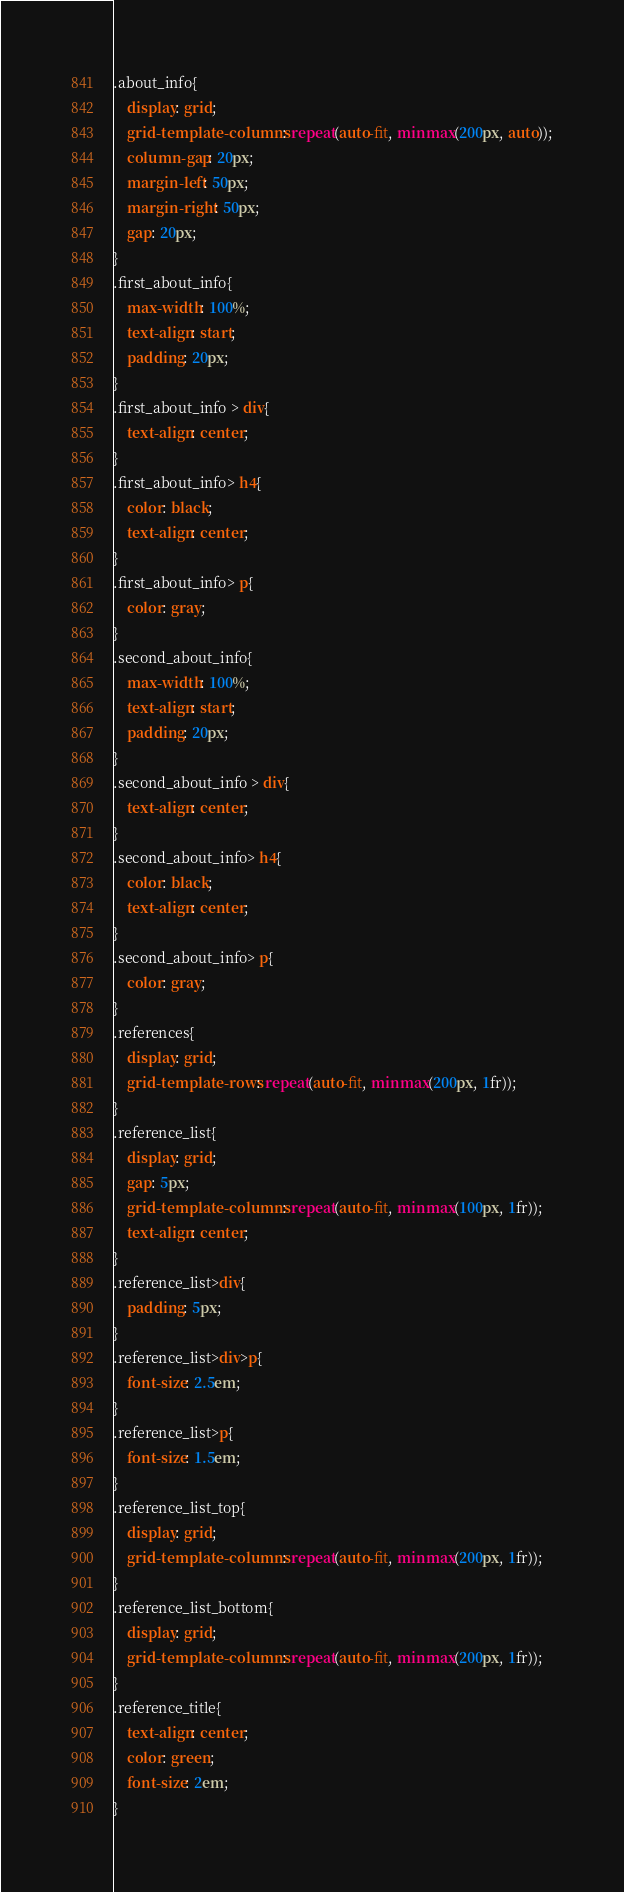Convert code to text. <code><loc_0><loc_0><loc_500><loc_500><_CSS_>.about_info{
    display: grid;
    grid-template-columns: repeat(auto-fit, minmax(200px, auto));
    column-gap: 20px;
    margin-left: 50px;
    margin-right: 50px;
    gap: 20px;
}
.first_about_info{
    max-width: 100%;
    text-align: start;
    padding: 20px;
}
.first_about_info > div{
    text-align: center;
}
.first_about_info> h4{
    color: black;
    text-align: center;
}
.first_about_info> p{
    color: gray;
}
.second_about_info{
    max-width: 100%;
    text-align: start;
    padding: 20px;
}
.second_about_info > div{
    text-align: center;
}
.second_about_info> h4{
    color: black;
    text-align: center;
}
.second_about_info> p{
    color: gray;
}
.references{
    display: grid;
    grid-template-rows: repeat(auto-fit, minmax(200px, 1fr));
}
.reference_list{
    display: grid;
    gap: 5px;
    grid-template-columns: repeat(auto-fit, minmax(100px, 1fr));
    text-align: center;
}
.reference_list>div{
    padding: 5px;
}
.reference_list>div>p{
    font-size: 2.5em;
}
.reference_list>p{
    font-size: 1.5em;
}
.reference_list_top{
    display: grid;
    grid-template-columns: repeat(auto-fit, minmax(200px, 1fr));
}
.reference_list_bottom{
    display: grid;
    grid-template-columns: repeat(auto-fit, minmax(200px, 1fr));
}
.reference_title{
    text-align: center;
    color: green;
    font-size: 2em;
}</code> 